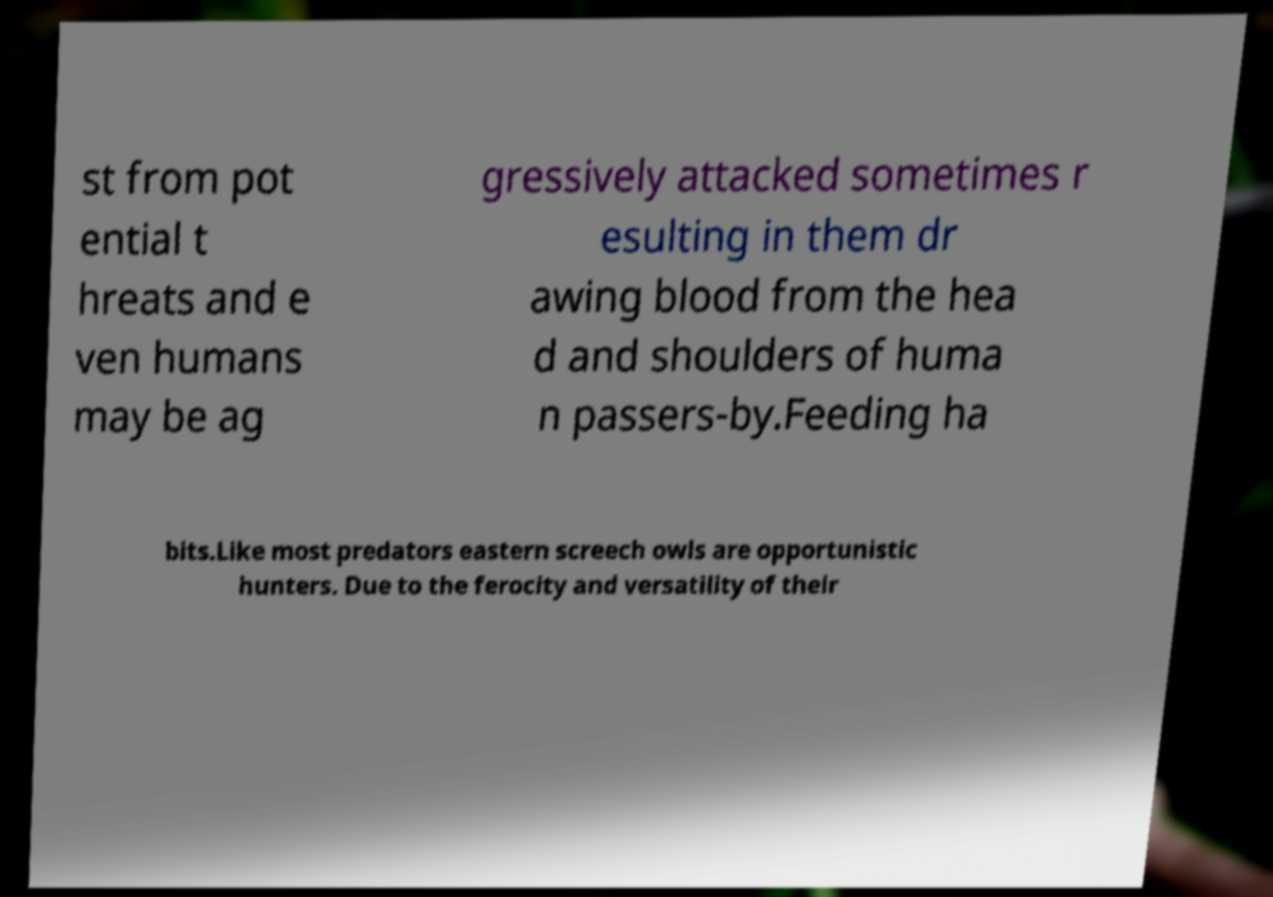I need the written content from this picture converted into text. Can you do that? st from pot ential t hreats and e ven humans may be ag gressively attacked sometimes r esulting in them dr awing blood from the hea d and shoulders of huma n passers-by.Feeding ha bits.Like most predators eastern screech owls are opportunistic hunters. Due to the ferocity and versatility of their 